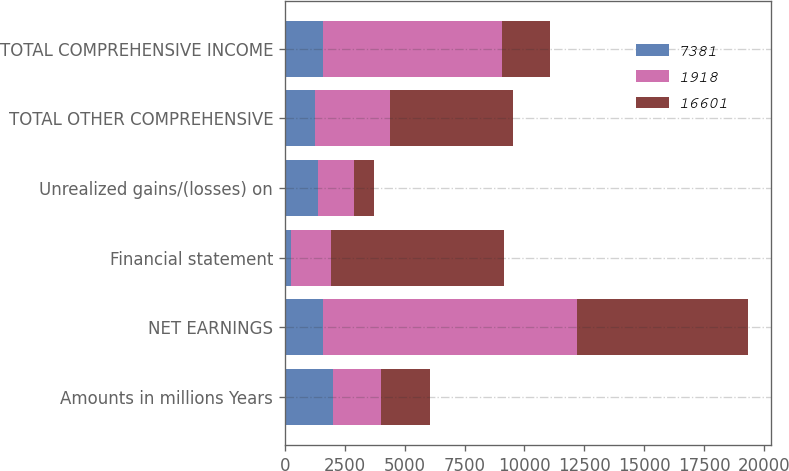<chart> <loc_0><loc_0><loc_500><loc_500><stacked_bar_chart><ecel><fcel>Amounts in millions Years<fcel>NET EARNINGS<fcel>Financial statement<fcel>Unrealized gains/(losses) on<fcel>TOTAL OTHER COMPREHENSIVE<fcel>TOTAL COMPREHENSIVE INCOME<nl><fcel>7381<fcel>2017<fcel>1578<fcel>239<fcel>1401<fcel>1275<fcel>1578<nl><fcel>1918<fcel>2016<fcel>10604<fcel>1679<fcel>1477<fcel>3127<fcel>7477<nl><fcel>16601<fcel>2015<fcel>7144<fcel>7220<fcel>844<fcel>5118<fcel>2026<nl></chart> 